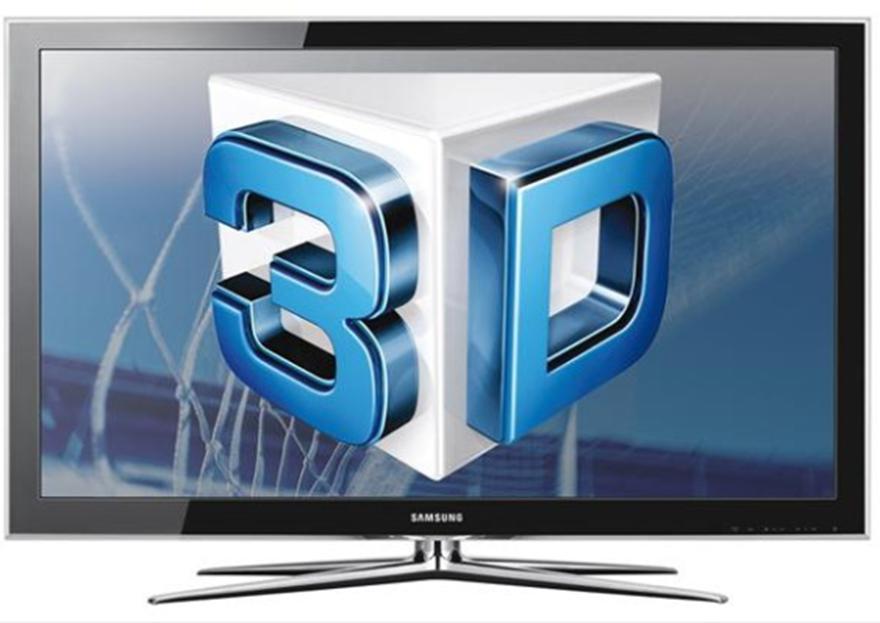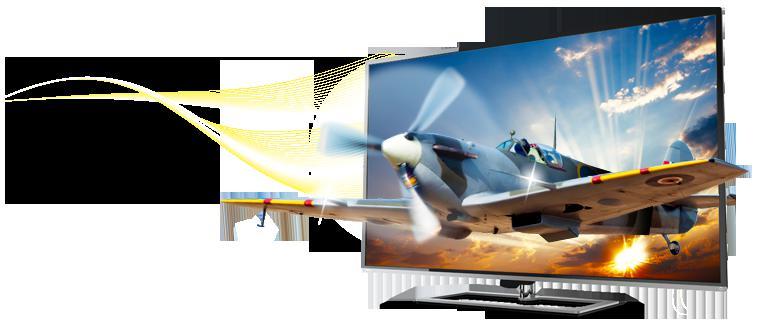The first image is the image on the left, the second image is the image on the right. For the images shown, is this caption "One of the TVs shows a type of aircraft on the screen, with part of the vehicle extending off the screen." true? Answer yes or no. Yes. The first image is the image on the left, the second image is the image on the right. Analyze the images presented: Is the assertion "There is a vehicle flying in the air on the screen of one of the monitors." valid? Answer yes or no. Yes. 